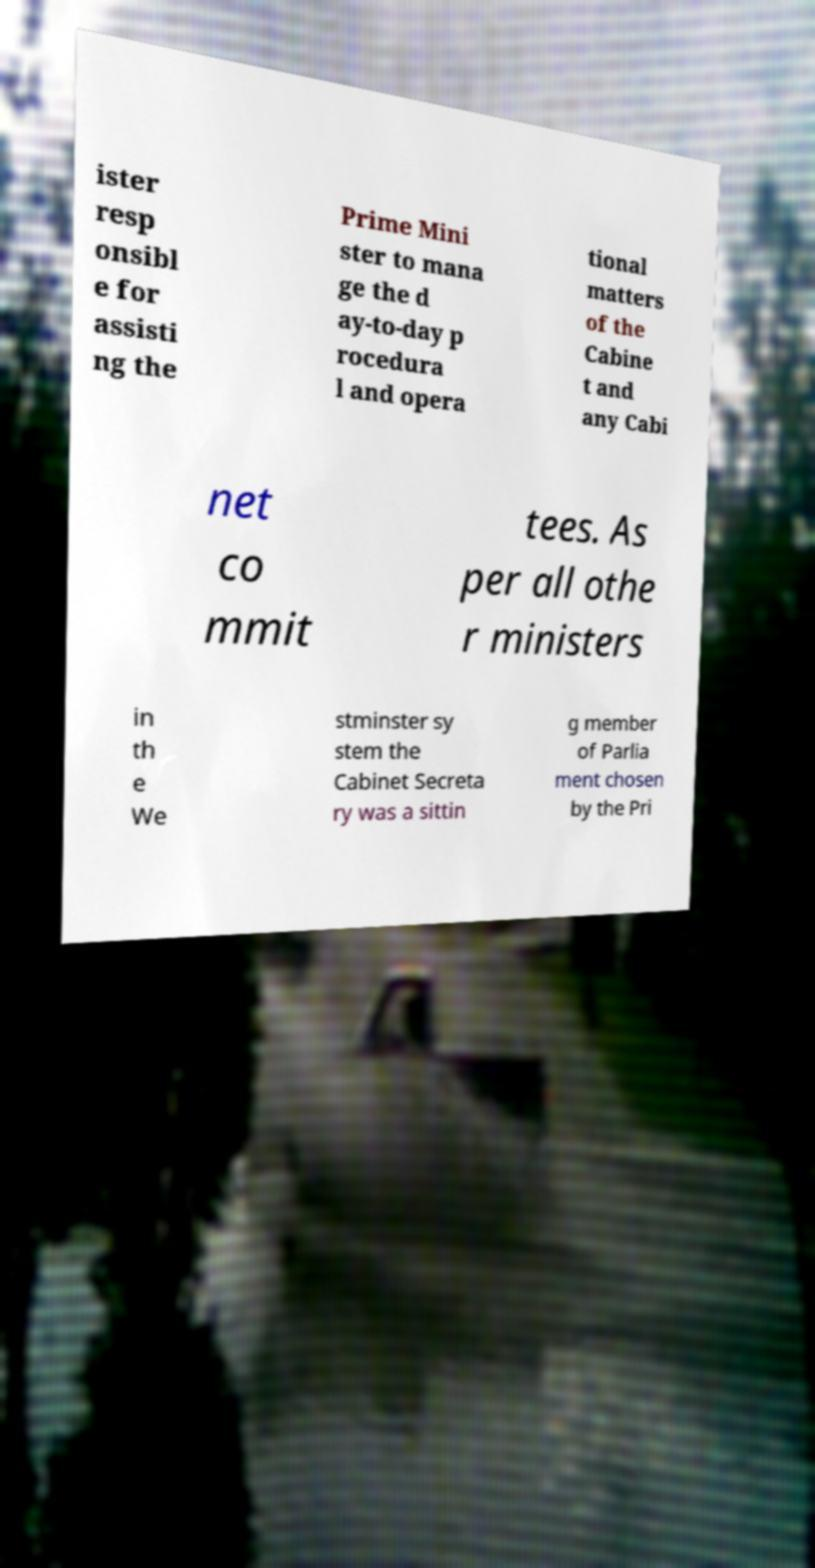Can you accurately transcribe the text from the provided image for me? ister resp onsibl e for assisti ng the Prime Mini ster to mana ge the d ay-to-day p rocedura l and opera tional matters of the Cabine t and any Cabi net co mmit tees. As per all othe r ministers in th e We stminster sy stem the Cabinet Secreta ry was a sittin g member of Parlia ment chosen by the Pri 